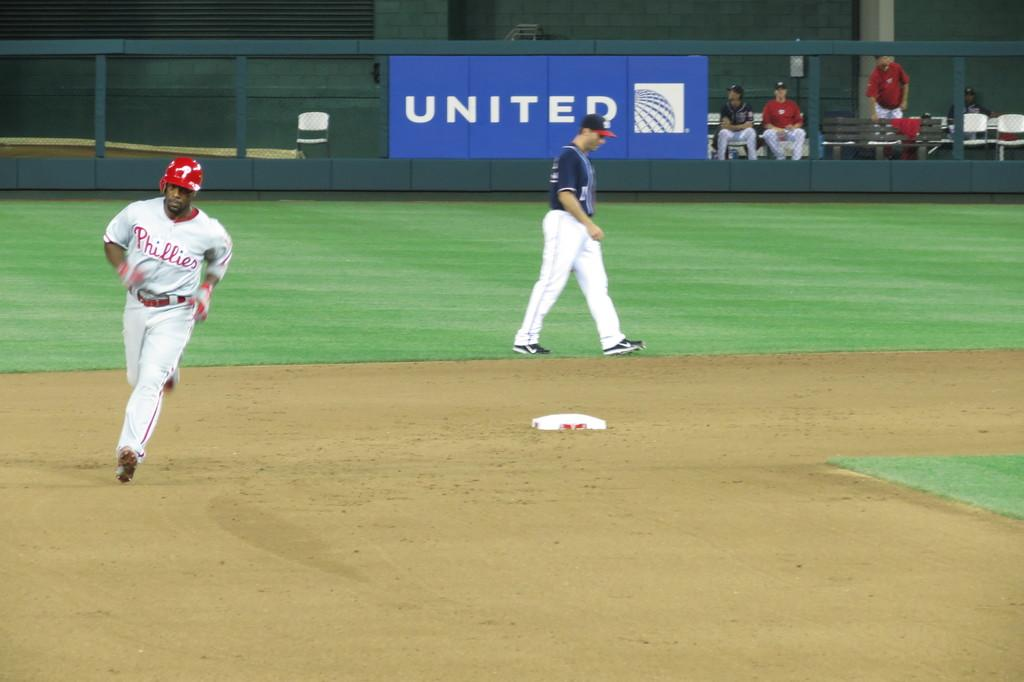<image>
Create a compact narrative representing the image presented. Baseball players on a field sponsored by United. 